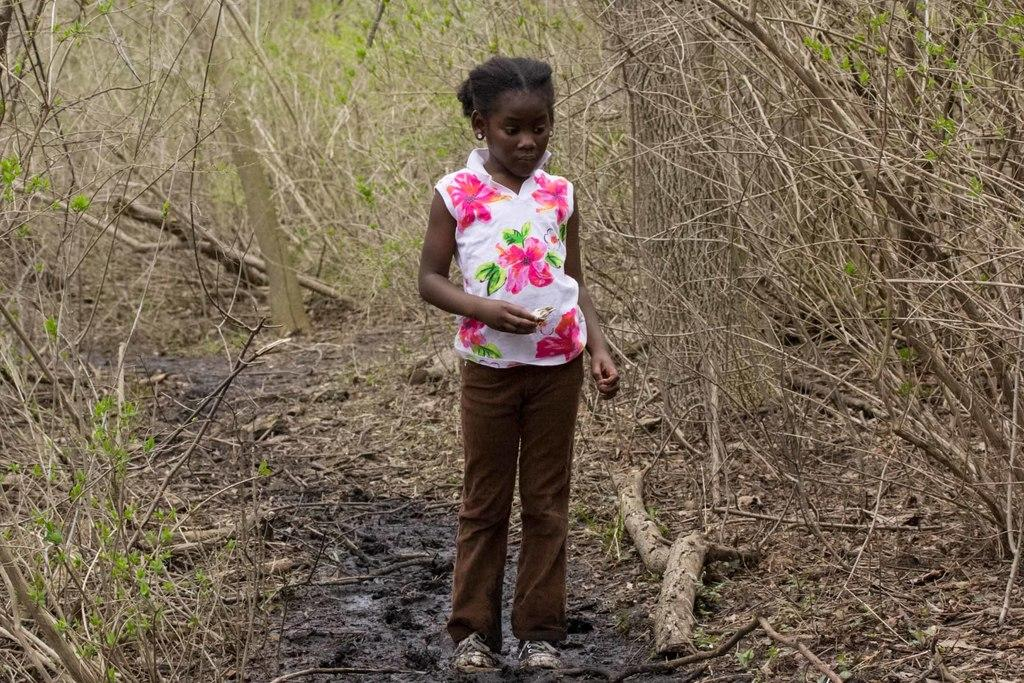What is the main subject of the image? There is a child in the image. What is the child doing in the image? The child is standing on the ground. What is the child holding in the image? The child is holding an object. What can be seen in the background of the image? There are trees in the background of the image. What type of curve can be seen in the image? There is no curve present in the image. How many times does the child sneeze in the image? The image does not show the child sneezing, so it cannot be determined how many times they sneeze. 